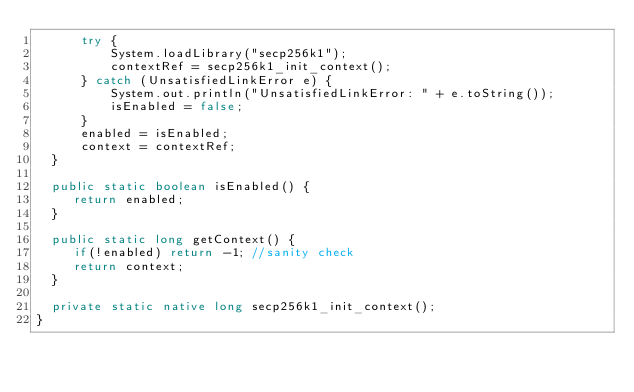Convert code to text. <code><loc_0><loc_0><loc_500><loc_500><_Java_>      try {
          System.loadLibrary("secp256k1");
          contextRef = secp256k1_init_context();
      } catch (UnsatisfiedLinkError e) {
          System.out.println("UnsatisfiedLinkError: " + e.toString());
          isEnabled = false;
      }
      enabled = isEnabled;
      context = contextRef;
  }

  public static boolean isEnabled() {
     return enabled;
  }

  public static long getContext() {
     if(!enabled) return -1; //sanity check
     return context;
  }

  private static native long secp256k1_init_context();
}
</code> 